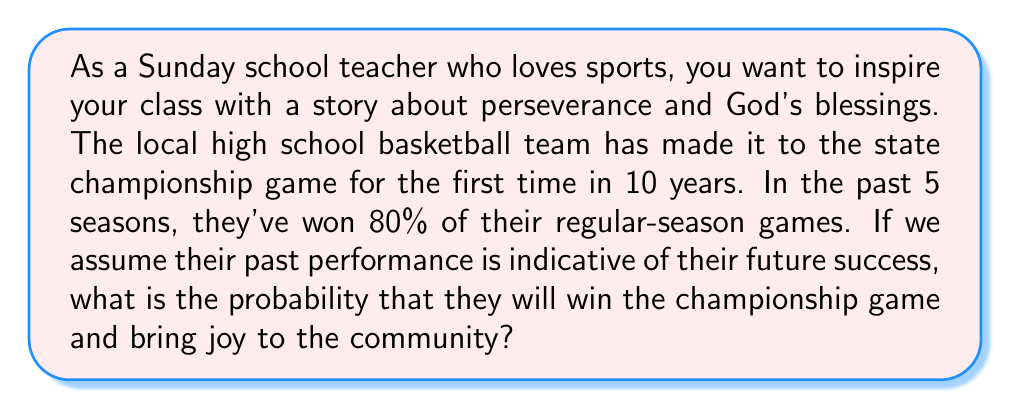Can you answer this question? To solve this problem, we need to understand that the team's past performance can be used as an estimate of their future success. In this case, we're given that the team has won 80% of their regular-season games over the past 5 seasons.

Let's break down the solution step-by-step:

1. Identify the given probability:
   The team's win rate is 80% or 0.80

2. Understand what this probability represents:
   This 0.80 represents the likelihood of the team winning any given game based on their past performance.

3. Assume this probability applies to the championship game:
   Since we're told to assume past performance is indicative of future success, we can use this same probability for the championship game.

4. Express the probability mathematically:
   $$P(\text{winning championship}) = 0.80$$

Therefore, based on their past performance, the probability of the team winning the championship game is 0.80 or 80%.

It's important to note that in reality, many other factors could influence the outcome of a championship game. However, for the purposes of this statistical exercise, we're using only the given information about past performance.
Answer: The probability that the high school basketball team will win the championship game, based on their past performance, is $0.80$ or $80\%$. 